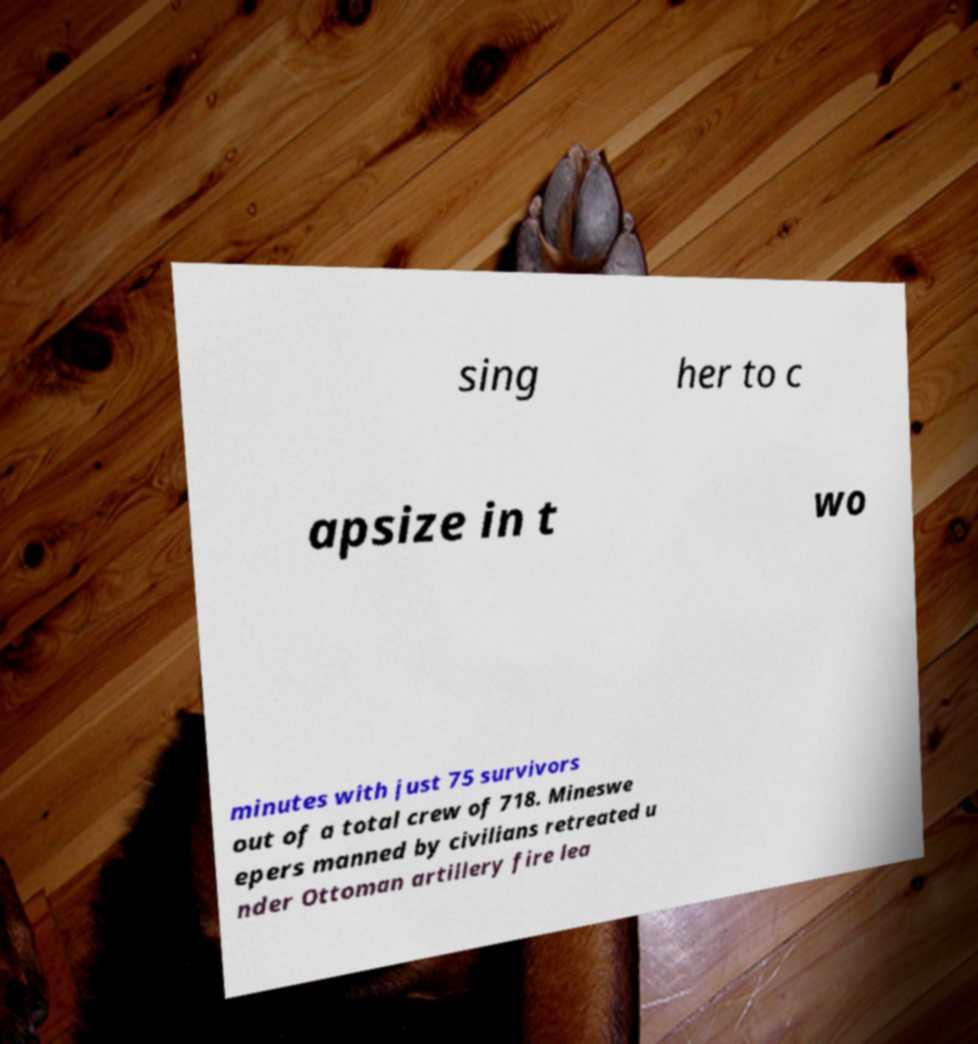Can you accurately transcribe the text from the provided image for me? sing her to c apsize in t wo minutes with just 75 survivors out of a total crew of 718. Mineswe epers manned by civilians retreated u nder Ottoman artillery fire lea 